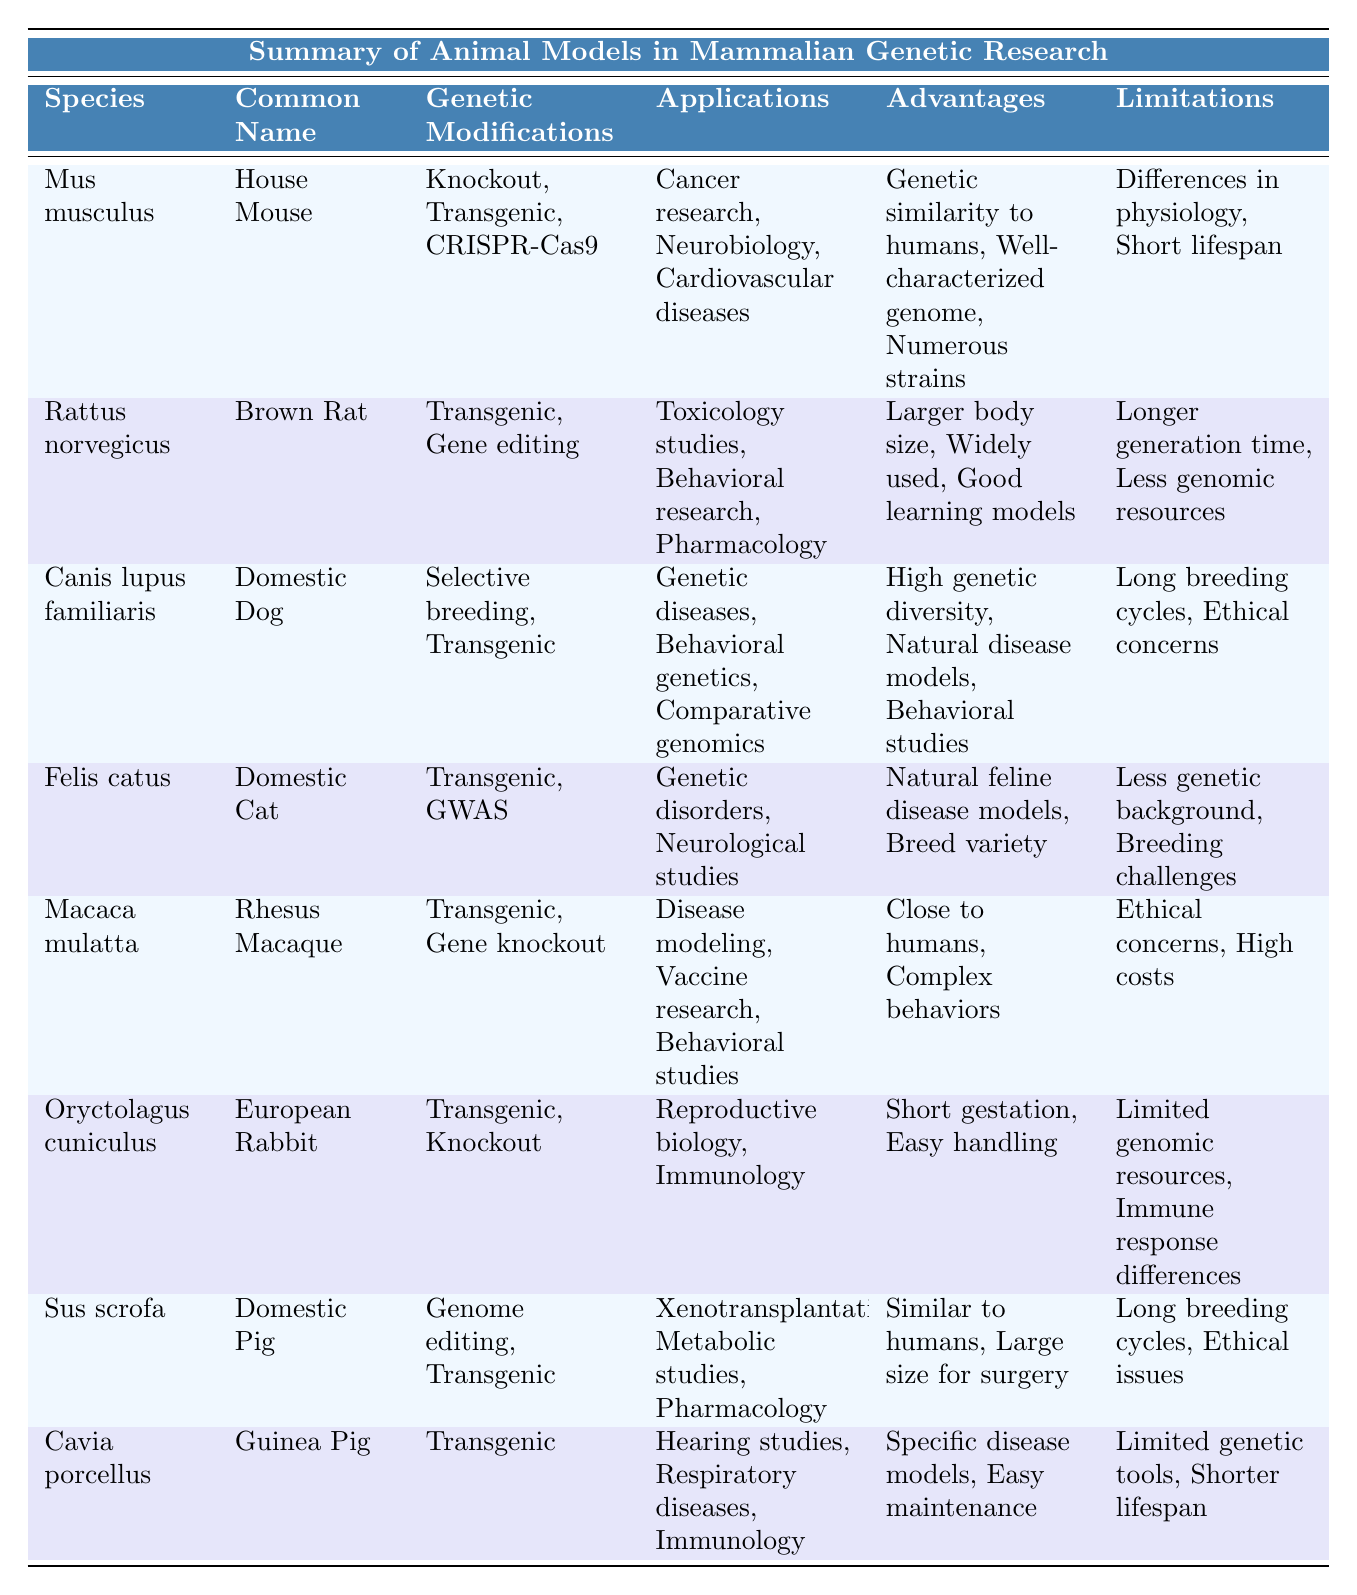What is the common name of the species "Mus musculus"? The table indicates the common name associated with the species "Mus musculus" in the respective row, which is "House Mouse."
Answer: House Mouse Which animal model has the genetic modification technique CRISPR-Cas9? In the table, looking at the rows, the animal model that has CRISPR-Cas9 as one of its genetic modifications is "Mus musculus."
Answer: Mus musculus How many applications are listed for the Domestic Dog? Referring to the row for "Canis lupus familiaris," there are three applications listed: "Genetic diseases," "Behavioral genetics," and "Comparative genomics."
Answer: Three What are the advantages of using the Rhesus Macaque in research? The advantages listed in the table for "Macaca mulatta" include "Closer genetic relationship to humans" and "Complex behaviors."
Answer: Closer genetic relationship to humans, Complex behaviors Which animal model has the most significant limitations according to the table? Comparing the limitations for all species in the table, "Canis lupus familiaris" and "Macaca mulatta" both have significant limitations, including long breeding cycles and ethical concerns; however, "Macaca mulatta" also has high maintenance costs making it standout in challenges.
Answer: Macaca mulatta Do domestic pigs have short breeding cycles according to the table? The table indicates that the limitations for "Sus scrofa" include "Long breeding cycles," which implies that they do not have short breeding cycles.
Answer: No Count the number of different genetic modifications used across all animal models. Reviewing the table, the genetic modifications are: "Knockout," "Transgenic," "CRISPR-Cas9," "Gene editing," "Selective breeding," "GWAS," and "Genome editing." Counting these, there are a total of 6 unique modifications used.
Answer: Six Which animal model is used primarily for immunology studies? Looking at the applications listed, "Oryctolagus cuniculus" (European Rabbit) and "Cavia porcellus" (Guinea Pig) both are mentioned for immunology studies, but the table specifies that they are used in that application.
Answer: European Rabbit, Guinea Pig Is the Domestic Cat used for behavioral genetics research? By checking the table, the applications for "Felis catus" do not include behavioral genetics; this is associated with "Canis lupus familiaris." Therefore, the statement is false.
Answer: No What is the physiological similarity advantage cited for the Domestic Pig? The row for "Sus scrofa" mentions "Physiological similarities to humans" as an advantage, confirming that this is one of the benefits of using this model.
Answer: Physiological similarities to humans Compare the genetic modifications of the House Mouse and the Brown Rat. The House Mouse employs "Knockout," "Transgenic," and "CRISPR-Cas9," while the Brown Rat utilizes "Transgenic" and "Gene editing." The comparison shows that both have transgenic, but House Mouse has additional modifications.
Answer: House Mouse has more modifications 